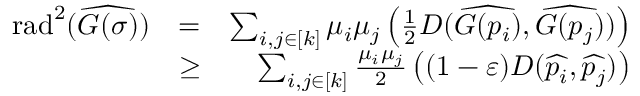Convert formula to latex. <formula><loc_0><loc_0><loc_500><loc_500>\begin{array} { r l r } { { r a d } ^ { 2 } ( \widehat { G ( \sigma ) } ) } & { = } & { \sum _ { i , j \in [ k ] } \mu _ { i } \mu _ { j } { \left ( \frac { 1 } { 2 } D ( \widehat { G ( p _ { i } ) } , \widehat { G ( p _ { j } ) } ) \right ) } } \\ & { \geq } & { \sum _ { i , j \in [ k ] } \frac { \mu _ { i } \mu _ { j } } { 2 } { \left ( ( 1 - { \varepsilon } ) D ( \widehat { p _ { i } } , \widehat { p _ { j } } ) \right ) } } \end{array}</formula> 